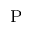Convert formula to latex. <formula><loc_0><loc_0><loc_500><loc_500>_ { P }</formula> 